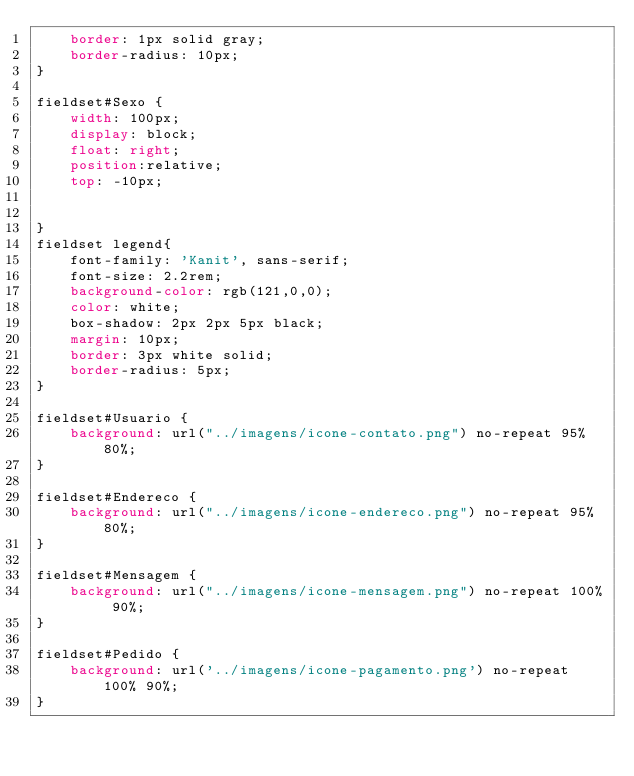Convert code to text. <code><loc_0><loc_0><loc_500><loc_500><_CSS_>    border: 1px solid gray;
    border-radius: 10px;
}

fieldset#Sexo {
    width: 100px;
    display: block;
    float: right;
    position:relative;
    top: -10px;
    

}
fieldset legend{
    font-family: 'Kanit', sans-serif;
    font-size: 2.2rem;
    background-color: rgb(121,0,0);
    color: white;
    box-shadow: 2px 2px 5px black;
    margin: 10px;
    border: 3px white solid;
    border-radius: 5px;
}

fieldset#Usuario {
    background: url("../imagens/icone-contato.png") no-repeat 95% 80%;
}

fieldset#Endereco {
    background: url("../imagens/icone-endereco.png") no-repeat 95% 80%;
}

fieldset#Mensagem {
    background: url("../imagens/icone-mensagem.png") no-repeat 100% 90%;
}

fieldset#Pedido {
    background: url('../imagens/icone-pagamento.png') no-repeat 100% 90%;
}

</code> 